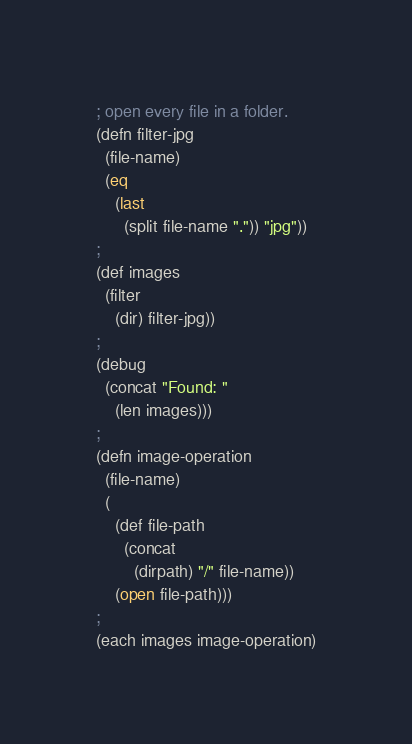<code> <loc_0><loc_0><loc_500><loc_500><_Lisp_>; open every file in a folder.
(defn filter-jpg 
  (file-name) 
  (eq 
    (last 
      (split file-name ".")) "jpg"))
;
(def images 
  (filter 
    (dir) filter-jpg))
;
(debug 
  (concat "Found: " 
    (len images)))
;
(defn image-operation 
  (file-name) 
  (
    (def file-path 
      (concat 
        (dirpath) "/" file-name)) 
    (open file-path)))
;
(each images image-operation)</code> 